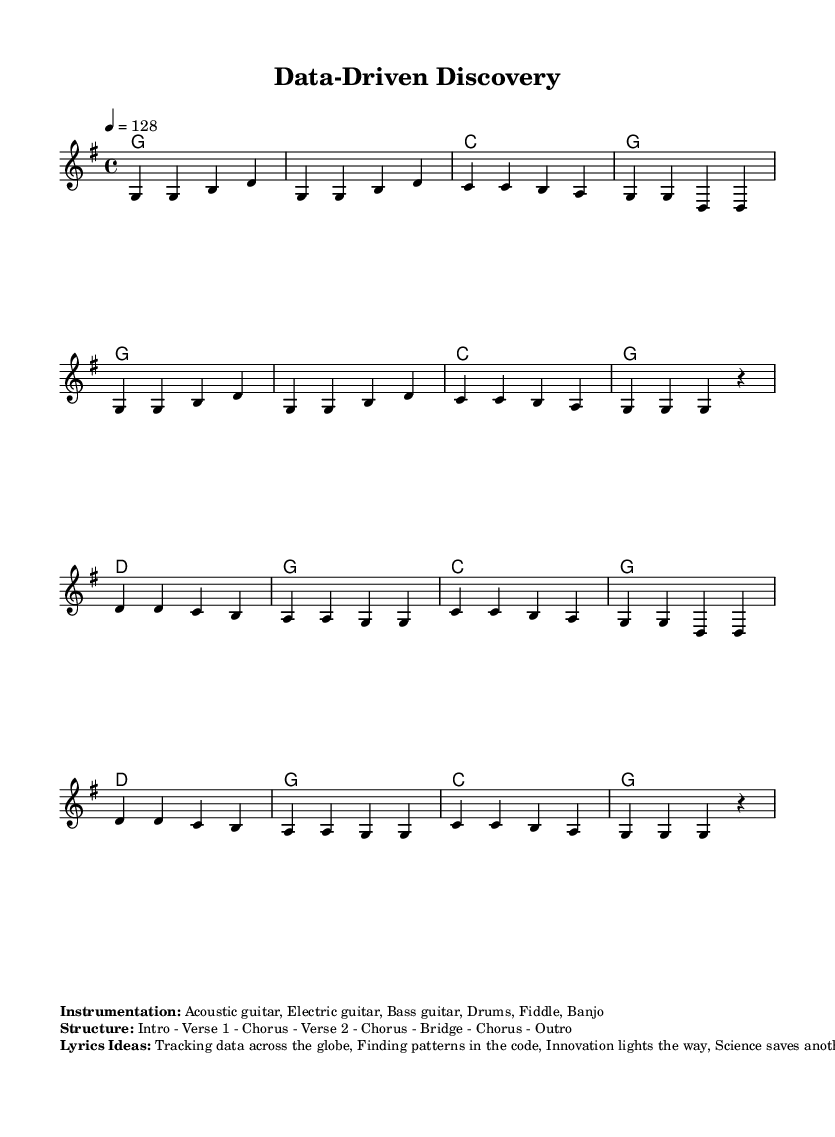What is the key signature of this music? The key signature is G major, which has one sharp (F#). This is indicated at the beginning of the staff with a sharp sign in the key signature section.
Answer: G major What is the time signature of this music? The time signature is 4/4, which means there are four beats in each measure and the quarter note gets one beat. This is indicated at the beginning where the time signature is displayed prominently.
Answer: 4/4 What is the tempo marking of this piece? The tempo marking is given as quarter note = 128, which means that each quarter note should be played at a speed of 128 beats per minute. This is shown near the top of the score.
Answer: 128 How many measures are in the chorus section? The chorus section consists of 8 measures, as counted from the notated music from the beginning of the chorus until its end. This can be seen by reviewing the measures explicitly marked for the chorus.
Answer: 8 What is the structure of this piece? The structure is outlined as Intro - Verse 1 - Chorus - Verse 2 - Chorus - Bridge - Chorus - Outro. This is indicated in the markup section that details the overall form of the music.
Answer: Intro - Verse 1 - Chorus - Verse 2 - Chorus - Bridge - Chorus - Outro What instruments are featured in this composition? The instruments listed include Acoustic guitar, Electric guitar, Bass guitar, Drums, Fiddle, and Banjo, which are specified in the markup section detailing the instrumentation used in the piece.
Answer: Acoustic guitar, Electric guitar, Bass guitar, Drums, Fiddle, Banjo What are the thematic lyrics ideas suggested for this piece? The suggested lyrical ideas focus on themes such as tracking data, finding patterns, and celebrating innovation in science, as described in the lyrics ideas section of the markup.
Answer: Tracking data across the globe, Finding patterns in the code, Innovation lights the way, Science saves another day 